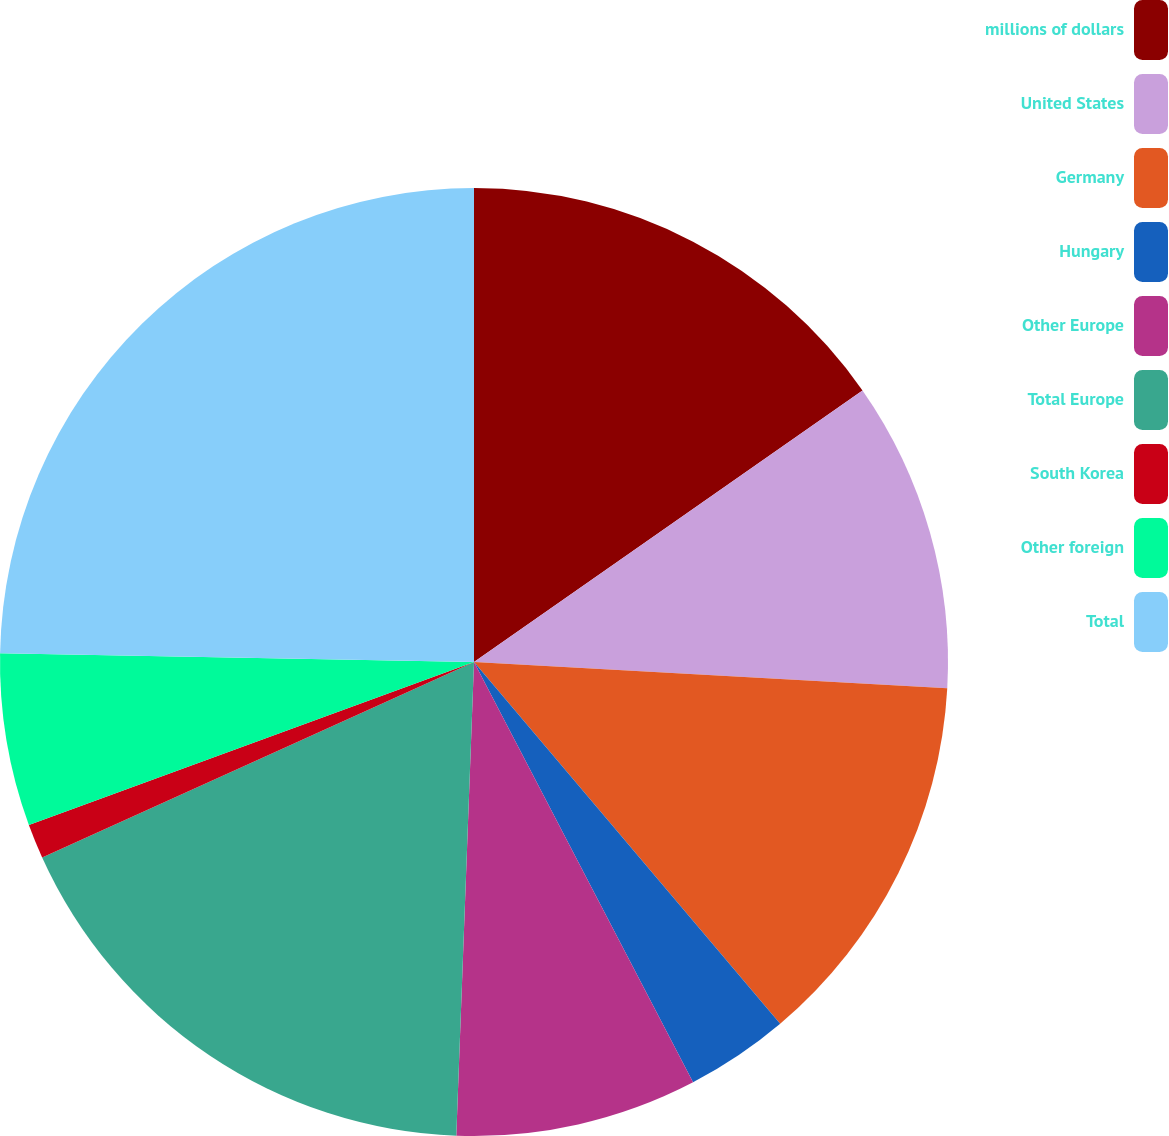Convert chart to OTSL. <chart><loc_0><loc_0><loc_500><loc_500><pie_chart><fcel>millions of dollars<fcel>United States<fcel>Germany<fcel>Hungary<fcel>Other Europe<fcel>Total Europe<fcel>South Korea<fcel>Other foreign<fcel>Total<nl><fcel>15.29%<fcel>10.59%<fcel>12.94%<fcel>3.53%<fcel>8.24%<fcel>17.64%<fcel>1.18%<fcel>5.88%<fcel>24.7%<nl></chart> 